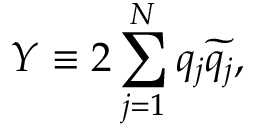<formula> <loc_0><loc_0><loc_500><loc_500>Y \equiv 2 \sum _ { j = 1 } ^ { N } q _ { j } \widetilde { q _ { j } } ,</formula> 